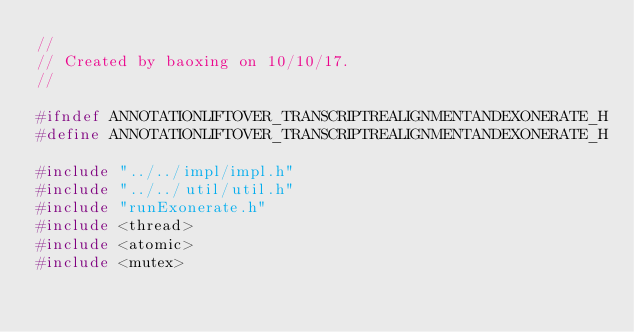<code> <loc_0><loc_0><loc_500><loc_500><_C_>//
// Created by baoxing on 10/10/17.
//

#ifndef ANNOTATIONLIFTOVER_TRANSCRIPTREALIGNMENTANDEXONERATE_H
#define ANNOTATIONLIFTOVER_TRANSCRIPTREALIGNMENTANDEXONERATE_H

#include "../../impl/impl.h"
#include "../../util/util.h"
#include "runExonerate.h"
#include <thread>
#include <atomic>
#include <mutex></code> 